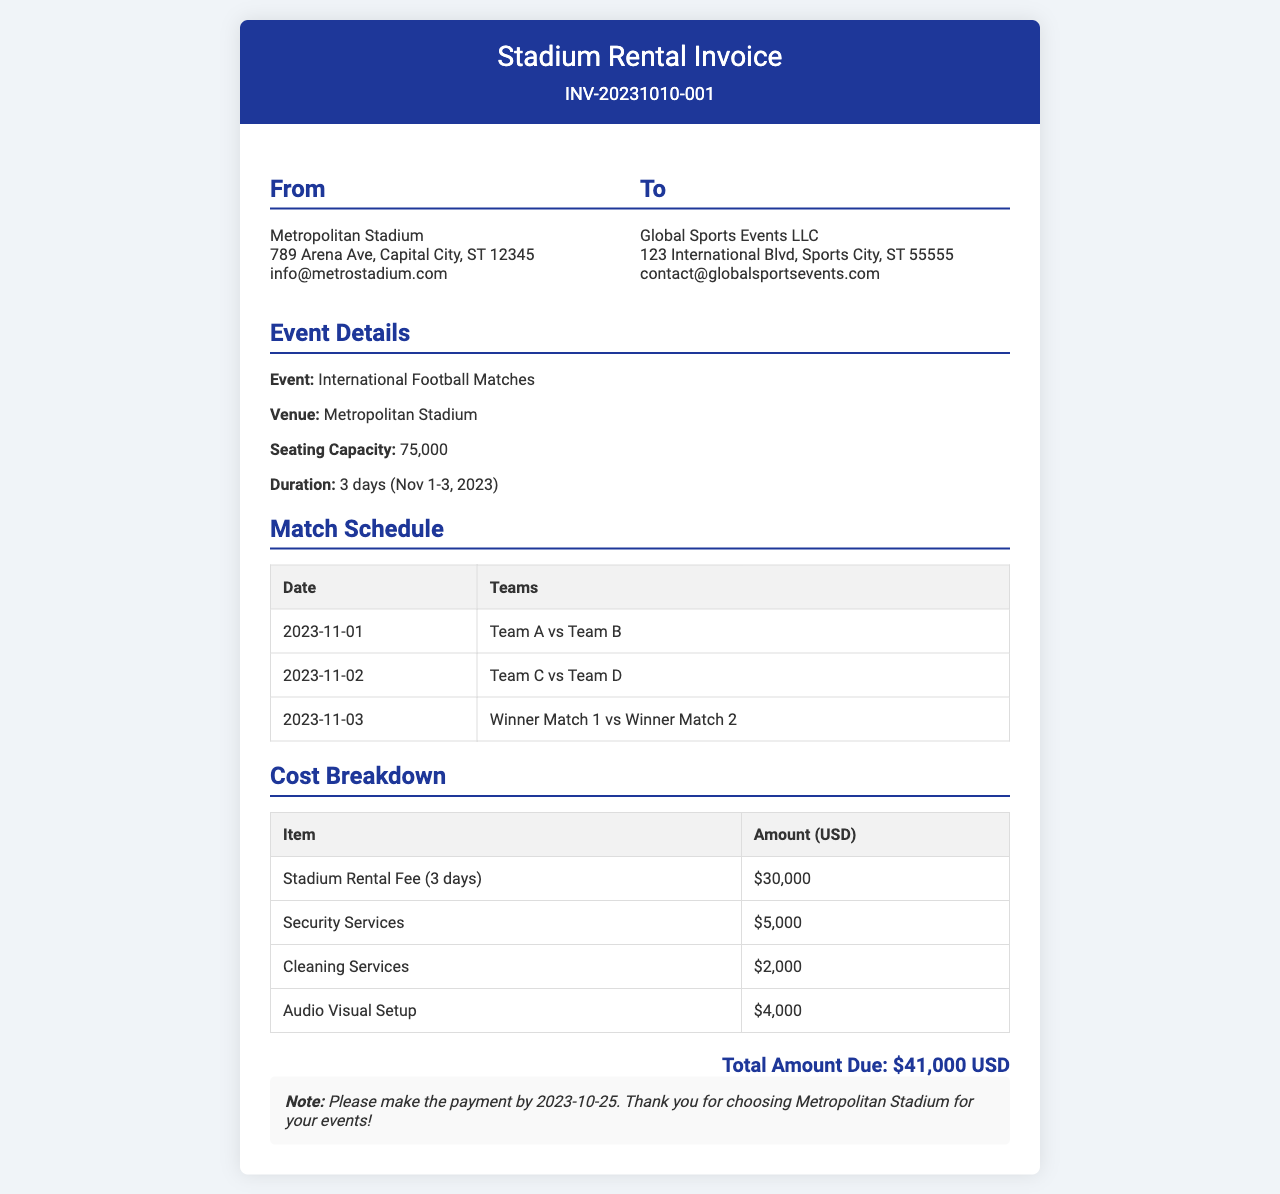What is the seating capacity of the stadium? The seating capacity is specified in the document as a specific number, which is 75,000.
Answer: 75,000 What is the duration of the event? The duration is mentioned with specific dates, which are 3 days from November 1 to November 3, 2023.
Answer: 3 days (Nov 1-3, 2023) How much is the total amount due? The total amount is clearly listed as the sum of different charges in the document, which is $41,000 USD.
Answer: $41,000 USD What is the rental fee for the stadium? The stadium rental fee is detailed under the cost breakdown as a specific amount for the given duration, which is $30,000.
Answer: $30,000 What additional service fee is listed for security services? The document specifies an additional service fee for security services, which is noted as $5,000.
Answer: $5,000 Which teams are playing on November 2? The match schedule includes a specific pairing for that date, which is Team C vs Team D.
Answer: Team C vs Team D What is the invoice number? The invoice number is presented prominently at the top of the document, which is INV-20231010-001.
Answer: INV-20231010-001 When is the payment due? The due date for payment is mentioned in the notes section of the document, which is 2023-10-25.
Answer: 2023-10-25 What services are included in the cost breakdown? The cost breakdown includes a list of services charged, such as Stadium Rental Fee, Security Services, Cleaning Services, and Audio Visual Setup.
Answer: Stadium Rental Fee, Security Services, Cleaning Services, Audio Visual Setup 